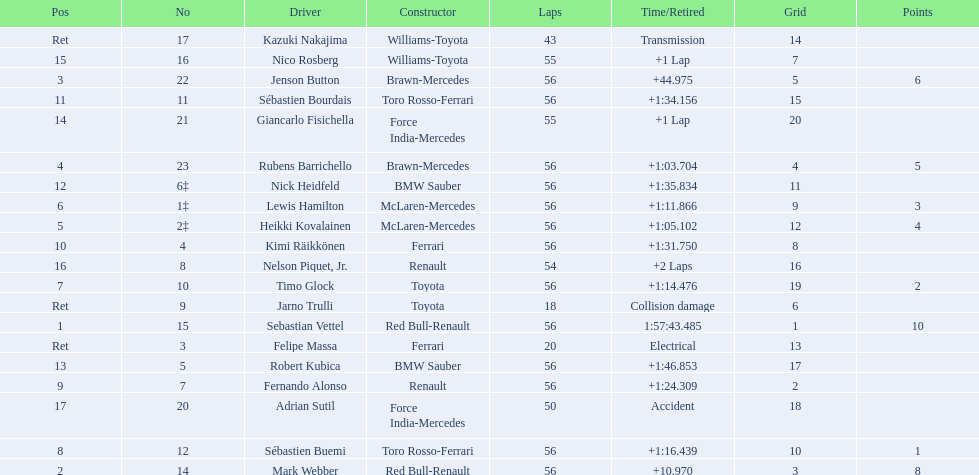Why did the  toyota retire Collision damage. What was the drivers name? Jarno Trulli. 